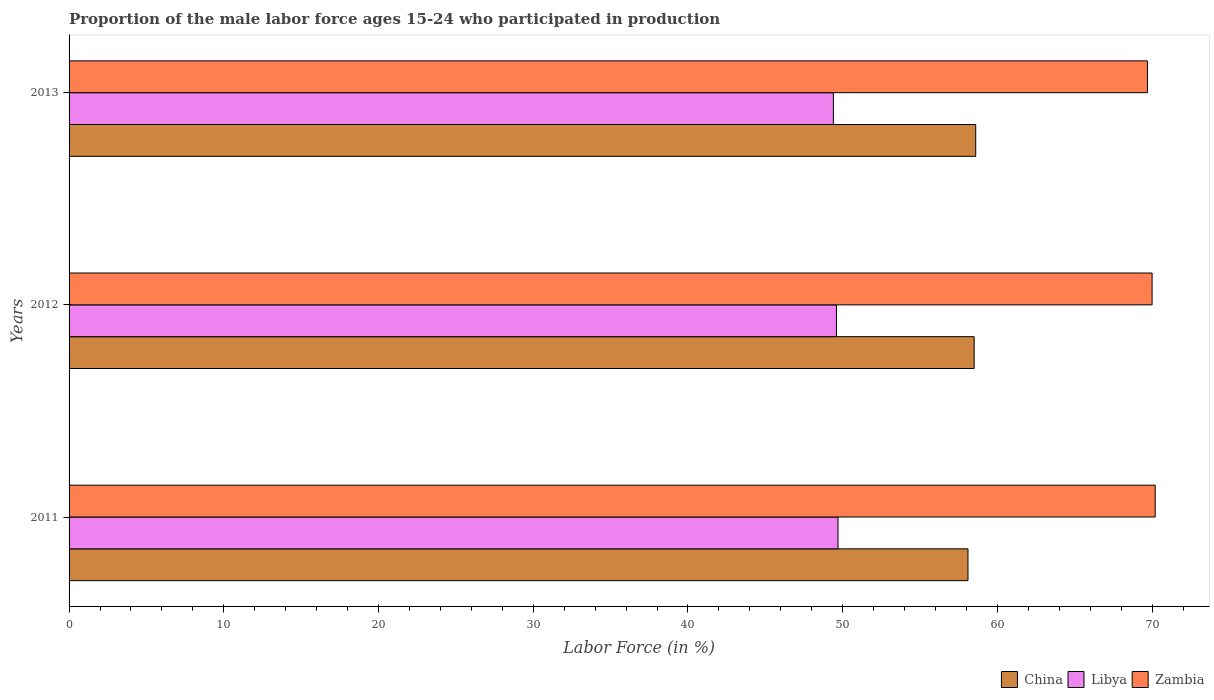How many different coloured bars are there?
Keep it short and to the point. 3. What is the proportion of the male labor force who participated in production in Libya in 2011?
Provide a short and direct response. 49.7. Across all years, what is the maximum proportion of the male labor force who participated in production in Libya?
Keep it short and to the point. 49.7. Across all years, what is the minimum proportion of the male labor force who participated in production in Zambia?
Keep it short and to the point. 69.7. What is the total proportion of the male labor force who participated in production in China in the graph?
Make the answer very short. 175.2. What is the difference between the proportion of the male labor force who participated in production in Zambia in 2011 and that in 2012?
Offer a very short reply. 0.2. What is the difference between the proportion of the male labor force who participated in production in Zambia in 2011 and the proportion of the male labor force who participated in production in Libya in 2013?
Keep it short and to the point. 20.8. What is the average proportion of the male labor force who participated in production in Libya per year?
Offer a very short reply. 49.57. In the year 2012, what is the difference between the proportion of the male labor force who participated in production in Zambia and proportion of the male labor force who participated in production in Libya?
Offer a very short reply. 20.4. In how many years, is the proportion of the male labor force who participated in production in China greater than 2 %?
Offer a very short reply. 3. What is the ratio of the proportion of the male labor force who participated in production in Libya in 2011 to that in 2013?
Offer a very short reply. 1.01. Is the proportion of the male labor force who participated in production in Zambia in 2011 less than that in 2013?
Give a very brief answer. No. What is the difference between the highest and the second highest proportion of the male labor force who participated in production in Zambia?
Offer a terse response. 0.2. What does the 1st bar from the top in 2013 represents?
Offer a very short reply. Zambia. What does the 3rd bar from the bottom in 2011 represents?
Ensure brevity in your answer.  Zambia. How many bars are there?
Provide a short and direct response. 9. Are all the bars in the graph horizontal?
Ensure brevity in your answer.  Yes. How many years are there in the graph?
Make the answer very short. 3. Are the values on the major ticks of X-axis written in scientific E-notation?
Offer a terse response. No. How are the legend labels stacked?
Provide a succinct answer. Horizontal. What is the title of the graph?
Give a very brief answer. Proportion of the male labor force ages 15-24 who participated in production. What is the label or title of the Y-axis?
Offer a terse response. Years. What is the Labor Force (in %) in China in 2011?
Offer a very short reply. 58.1. What is the Labor Force (in %) of Libya in 2011?
Make the answer very short. 49.7. What is the Labor Force (in %) of Zambia in 2011?
Make the answer very short. 70.2. What is the Labor Force (in %) of China in 2012?
Offer a very short reply. 58.5. What is the Labor Force (in %) of Libya in 2012?
Your answer should be very brief. 49.6. What is the Labor Force (in %) of Zambia in 2012?
Your answer should be compact. 70. What is the Labor Force (in %) in China in 2013?
Your answer should be compact. 58.6. What is the Labor Force (in %) in Libya in 2013?
Keep it short and to the point. 49.4. What is the Labor Force (in %) of Zambia in 2013?
Your answer should be very brief. 69.7. Across all years, what is the maximum Labor Force (in %) of China?
Your answer should be compact. 58.6. Across all years, what is the maximum Labor Force (in %) of Libya?
Your answer should be very brief. 49.7. Across all years, what is the maximum Labor Force (in %) of Zambia?
Make the answer very short. 70.2. Across all years, what is the minimum Labor Force (in %) in China?
Your answer should be compact. 58.1. Across all years, what is the minimum Labor Force (in %) of Libya?
Your answer should be compact. 49.4. Across all years, what is the minimum Labor Force (in %) of Zambia?
Your answer should be compact. 69.7. What is the total Labor Force (in %) of China in the graph?
Offer a terse response. 175.2. What is the total Labor Force (in %) of Libya in the graph?
Provide a short and direct response. 148.7. What is the total Labor Force (in %) of Zambia in the graph?
Provide a short and direct response. 209.9. What is the difference between the Labor Force (in %) of China in 2011 and that in 2012?
Provide a short and direct response. -0.4. What is the difference between the Labor Force (in %) in Libya in 2011 and that in 2013?
Ensure brevity in your answer.  0.3. What is the difference between the Labor Force (in %) of China in 2011 and the Labor Force (in %) of Libya in 2012?
Keep it short and to the point. 8.5. What is the difference between the Labor Force (in %) of China in 2011 and the Labor Force (in %) of Zambia in 2012?
Ensure brevity in your answer.  -11.9. What is the difference between the Labor Force (in %) of Libya in 2011 and the Labor Force (in %) of Zambia in 2012?
Your response must be concise. -20.3. What is the difference between the Labor Force (in %) of Libya in 2011 and the Labor Force (in %) of Zambia in 2013?
Provide a short and direct response. -20. What is the difference between the Labor Force (in %) in China in 2012 and the Labor Force (in %) in Libya in 2013?
Offer a terse response. 9.1. What is the difference between the Labor Force (in %) of China in 2012 and the Labor Force (in %) of Zambia in 2013?
Offer a terse response. -11.2. What is the difference between the Labor Force (in %) in Libya in 2012 and the Labor Force (in %) in Zambia in 2013?
Offer a very short reply. -20.1. What is the average Labor Force (in %) in China per year?
Provide a short and direct response. 58.4. What is the average Labor Force (in %) in Libya per year?
Ensure brevity in your answer.  49.57. What is the average Labor Force (in %) in Zambia per year?
Your answer should be very brief. 69.97. In the year 2011, what is the difference between the Labor Force (in %) in China and Labor Force (in %) in Zambia?
Give a very brief answer. -12.1. In the year 2011, what is the difference between the Labor Force (in %) of Libya and Labor Force (in %) of Zambia?
Offer a terse response. -20.5. In the year 2012, what is the difference between the Labor Force (in %) of China and Labor Force (in %) of Zambia?
Offer a very short reply. -11.5. In the year 2012, what is the difference between the Labor Force (in %) in Libya and Labor Force (in %) in Zambia?
Make the answer very short. -20.4. In the year 2013, what is the difference between the Labor Force (in %) of China and Labor Force (in %) of Zambia?
Your response must be concise. -11.1. In the year 2013, what is the difference between the Labor Force (in %) of Libya and Labor Force (in %) of Zambia?
Your response must be concise. -20.3. What is the ratio of the Labor Force (in %) of China in 2011 to that in 2012?
Your response must be concise. 0.99. What is the ratio of the Labor Force (in %) of Libya in 2011 to that in 2012?
Make the answer very short. 1. What is the ratio of the Labor Force (in %) in China in 2011 to that in 2013?
Your response must be concise. 0.99. What is the ratio of the Labor Force (in %) of China in 2012 to that in 2013?
Your answer should be compact. 1. What is the difference between the highest and the second highest Labor Force (in %) in China?
Your answer should be compact. 0.1. What is the difference between the highest and the second highest Labor Force (in %) in Zambia?
Your response must be concise. 0.2. What is the difference between the highest and the lowest Labor Force (in %) in China?
Offer a very short reply. 0.5. What is the difference between the highest and the lowest Labor Force (in %) in Libya?
Give a very brief answer. 0.3. 